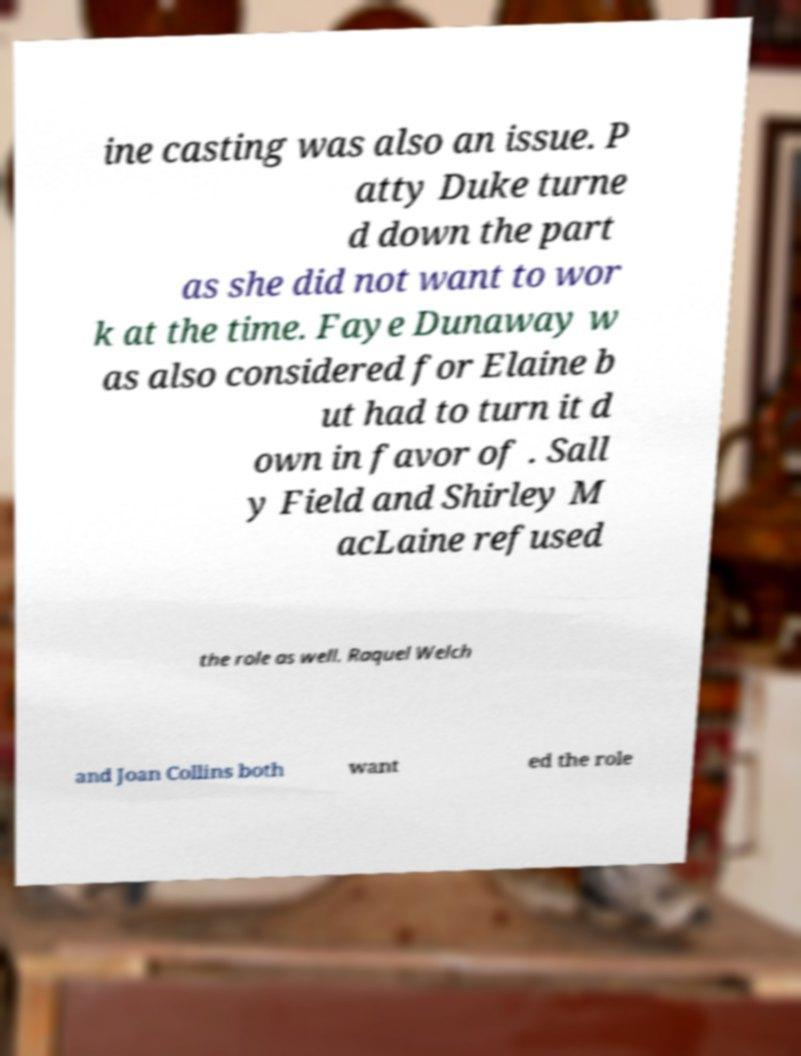For documentation purposes, I need the text within this image transcribed. Could you provide that? ine casting was also an issue. P atty Duke turne d down the part as she did not want to wor k at the time. Faye Dunaway w as also considered for Elaine b ut had to turn it d own in favor of . Sall y Field and Shirley M acLaine refused the role as well. Raquel Welch and Joan Collins both want ed the role 